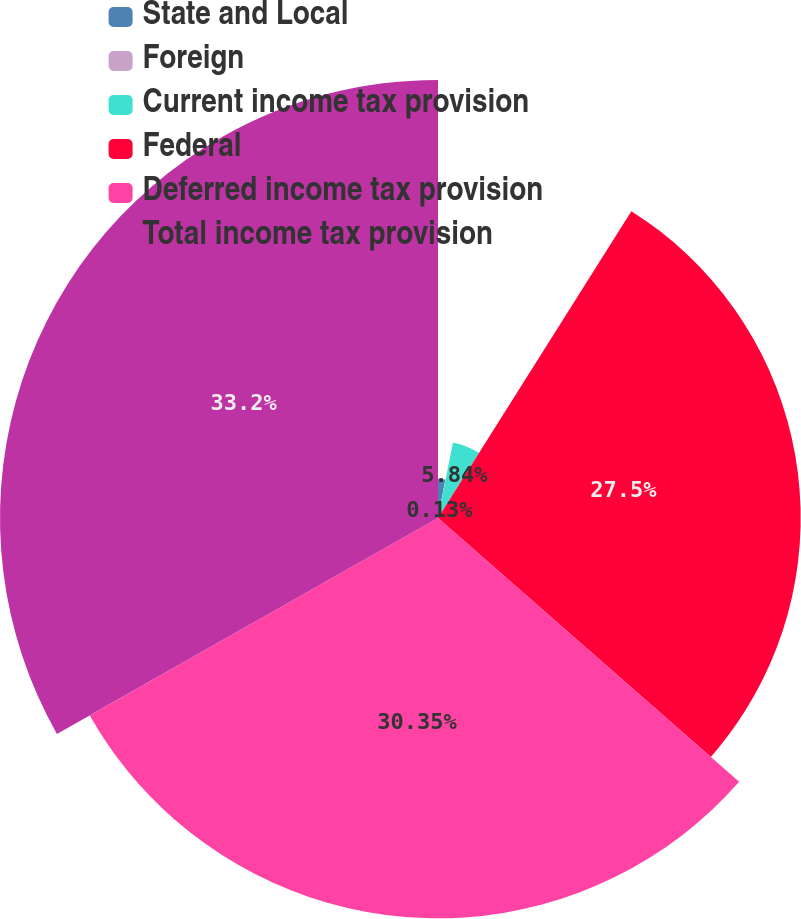Convert chart. <chart><loc_0><loc_0><loc_500><loc_500><pie_chart><fcel>State and Local<fcel>Foreign<fcel>Current income tax provision<fcel>Federal<fcel>Deferred income tax provision<fcel>Total income tax provision<nl><fcel>2.98%<fcel>0.13%<fcel>5.84%<fcel>27.5%<fcel>30.35%<fcel>33.21%<nl></chart> 